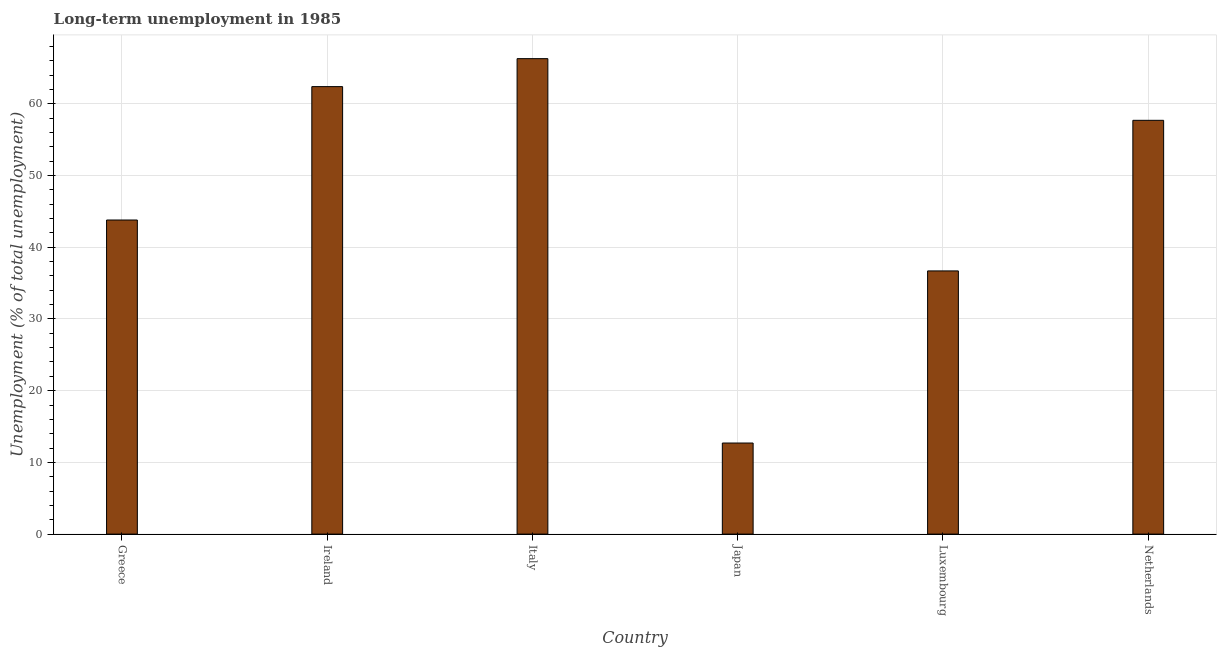Does the graph contain grids?
Make the answer very short. Yes. What is the title of the graph?
Provide a short and direct response. Long-term unemployment in 1985. What is the label or title of the X-axis?
Offer a terse response. Country. What is the label or title of the Y-axis?
Offer a very short reply. Unemployment (% of total unemployment). What is the long-term unemployment in Netherlands?
Keep it short and to the point. 57.7. Across all countries, what is the maximum long-term unemployment?
Your response must be concise. 66.3. Across all countries, what is the minimum long-term unemployment?
Provide a succinct answer. 12.7. In which country was the long-term unemployment minimum?
Keep it short and to the point. Japan. What is the sum of the long-term unemployment?
Give a very brief answer. 279.6. What is the difference between the long-term unemployment in Japan and Luxembourg?
Ensure brevity in your answer.  -24. What is the average long-term unemployment per country?
Provide a short and direct response. 46.6. What is the median long-term unemployment?
Keep it short and to the point. 50.75. In how many countries, is the long-term unemployment greater than 22 %?
Your answer should be very brief. 5. Is the long-term unemployment in Italy less than that in Japan?
Provide a short and direct response. No. Is the difference between the long-term unemployment in Ireland and Japan greater than the difference between any two countries?
Keep it short and to the point. No. Is the sum of the long-term unemployment in Japan and Luxembourg greater than the maximum long-term unemployment across all countries?
Give a very brief answer. No. What is the difference between the highest and the lowest long-term unemployment?
Give a very brief answer. 53.6. In how many countries, is the long-term unemployment greater than the average long-term unemployment taken over all countries?
Provide a short and direct response. 3. Are all the bars in the graph horizontal?
Give a very brief answer. No. How many countries are there in the graph?
Provide a succinct answer. 6. Are the values on the major ticks of Y-axis written in scientific E-notation?
Your response must be concise. No. What is the Unemployment (% of total unemployment) in Greece?
Keep it short and to the point. 43.8. What is the Unemployment (% of total unemployment) in Ireland?
Offer a terse response. 62.4. What is the Unemployment (% of total unemployment) of Italy?
Make the answer very short. 66.3. What is the Unemployment (% of total unemployment) in Japan?
Offer a terse response. 12.7. What is the Unemployment (% of total unemployment) in Luxembourg?
Ensure brevity in your answer.  36.7. What is the Unemployment (% of total unemployment) of Netherlands?
Make the answer very short. 57.7. What is the difference between the Unemployment (% of total unemployment) in Greece and Ireland?
Ensure brevity in your answer.  -18.6. What is the difference between the Unemployment (% of total unemployment) in Greece and Italy?
Ensure brevity in your answer.  -22.5. What is the difference between the Unemployment (% of total unemployment) in Greece and Japan?
Offer a terse response. 31.1. What is the difference between the Unemployment (% of total unemployment) in Greece and Netherlands?
Your answer should be compact. -13.9. What is the difference between the Unemployment (% of total unemployment) in Ireland and Japan?
Your answer should be compact. 49.7. What is the difference between the Unemployment (% of total unemployment) in Ireland and Luxembourg?
Ensure brevity in your answer.  25.7. What is the difference between the Unemployment (% of total unemployment) in Ireland and Netherlands?
Your answer should be very brief. 4.7. What is the difference between the Unemployment (% of total unemployment) in Italy and Japan?
Offer a terse response. 53.6. What is the difference between the Unemployment (% of total unemployment) in Italy and Luxembourg?
Your response must be concise. 29.6. What is the difference between the Unemployment (% of total unemployment) in Italy and Netherlands?
Make the answer very short. 8.6. What is the difference between the Unemployment (% of total unemployment) in Japan and Luxembourg?
Provide a short and direct response. -24. What is the difference between the Unemployment (% of total unemployment) in Japan and Netherlands?
Your answer should be very brief. -45. What is the ratio of the Unemployment (% of total unemployment) in Greece to that in Ireland?
Your answer should be very brief. 0.7. What is the ratio of the Unemployment (% of total unemployment) in Greece to that in Italy?
Make the answer very short. 0.66. What is the ratio of the Unemployment (% of total unemployment) in Greece to that in Japan?
Offer a very short reply. 3.45. What is the ratio of the Unemployment (% of total unemployment) in Greece to that in Luxembourg?
Your response must be concise. 1.19. What is the ratio of the Unemployment (% of total unemployment) in Greece to that in Netherlands?
Make the answer very short. 0.76. What is the ratio of the Unemployment (% of total unemployment) in Ireland to that in Italy?
Provide a succinct answer. 0.94. What is the ratio of the Unemployment (% of total unemployment) in Ireland to that in Japan?
Ensure brevity in your answer.  4.91. What is the ratio of the Unemployment (% of total unemployment) in Ireland to that in Netherlands?
Make the answer very short. 1.08. What is the ratio of the Unemployment (% of total unemployment) in Italy to that in Japan?
Give a very brief answer. 5.22. What is the ratio of the Unemployment (% of total unemployment) in Italy to that in Luxembourg?
Your answer should be compact. 1.81. What is the ratio of the Unemployment (% of total unemployment) in Italy to that in Netherlands?
Your answer should be very brief. 1.15. What is the ratio of the Unemployment (% of total unemployment) in Japan to that in Luxembourg?
Keep it short and to the point. 0.35. What is the ratio of the Unemployment (% of total unemployment) in Japan to that in Netherlands?
Offer a terse response. 0.22. What is the ratio of the Unemployment (% of total unemployment) in Luxembourg to that in Netherlands?
Your answer should be very brief. 0.64. 